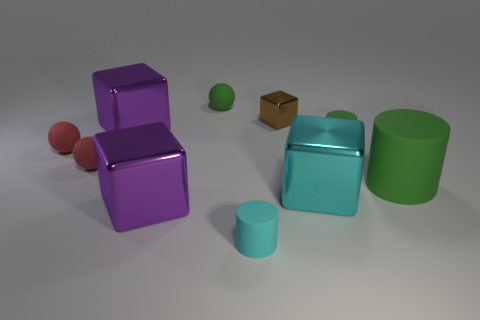Subtract all red cylinders. How many red spheres are left? 2 Subtract all red spheres. How many spheres are left? 1 Subtract all brown blocks. How many blocks are left? 3 Subtract all shiny cylinders. Subtract all large purple shiny cubes. How many objects are left? 8 Add 5 small cubes. How many small cubes are left? 6 Add 7 brown cubes. How many brown cubes exist? 8 Subtract 0 gray blocks. How many objects are left? 10 Subtract all balls. How many objects are left? 7 Subtract all blue balls. Subtract all yellow cylinders. How many balls are left? 3 